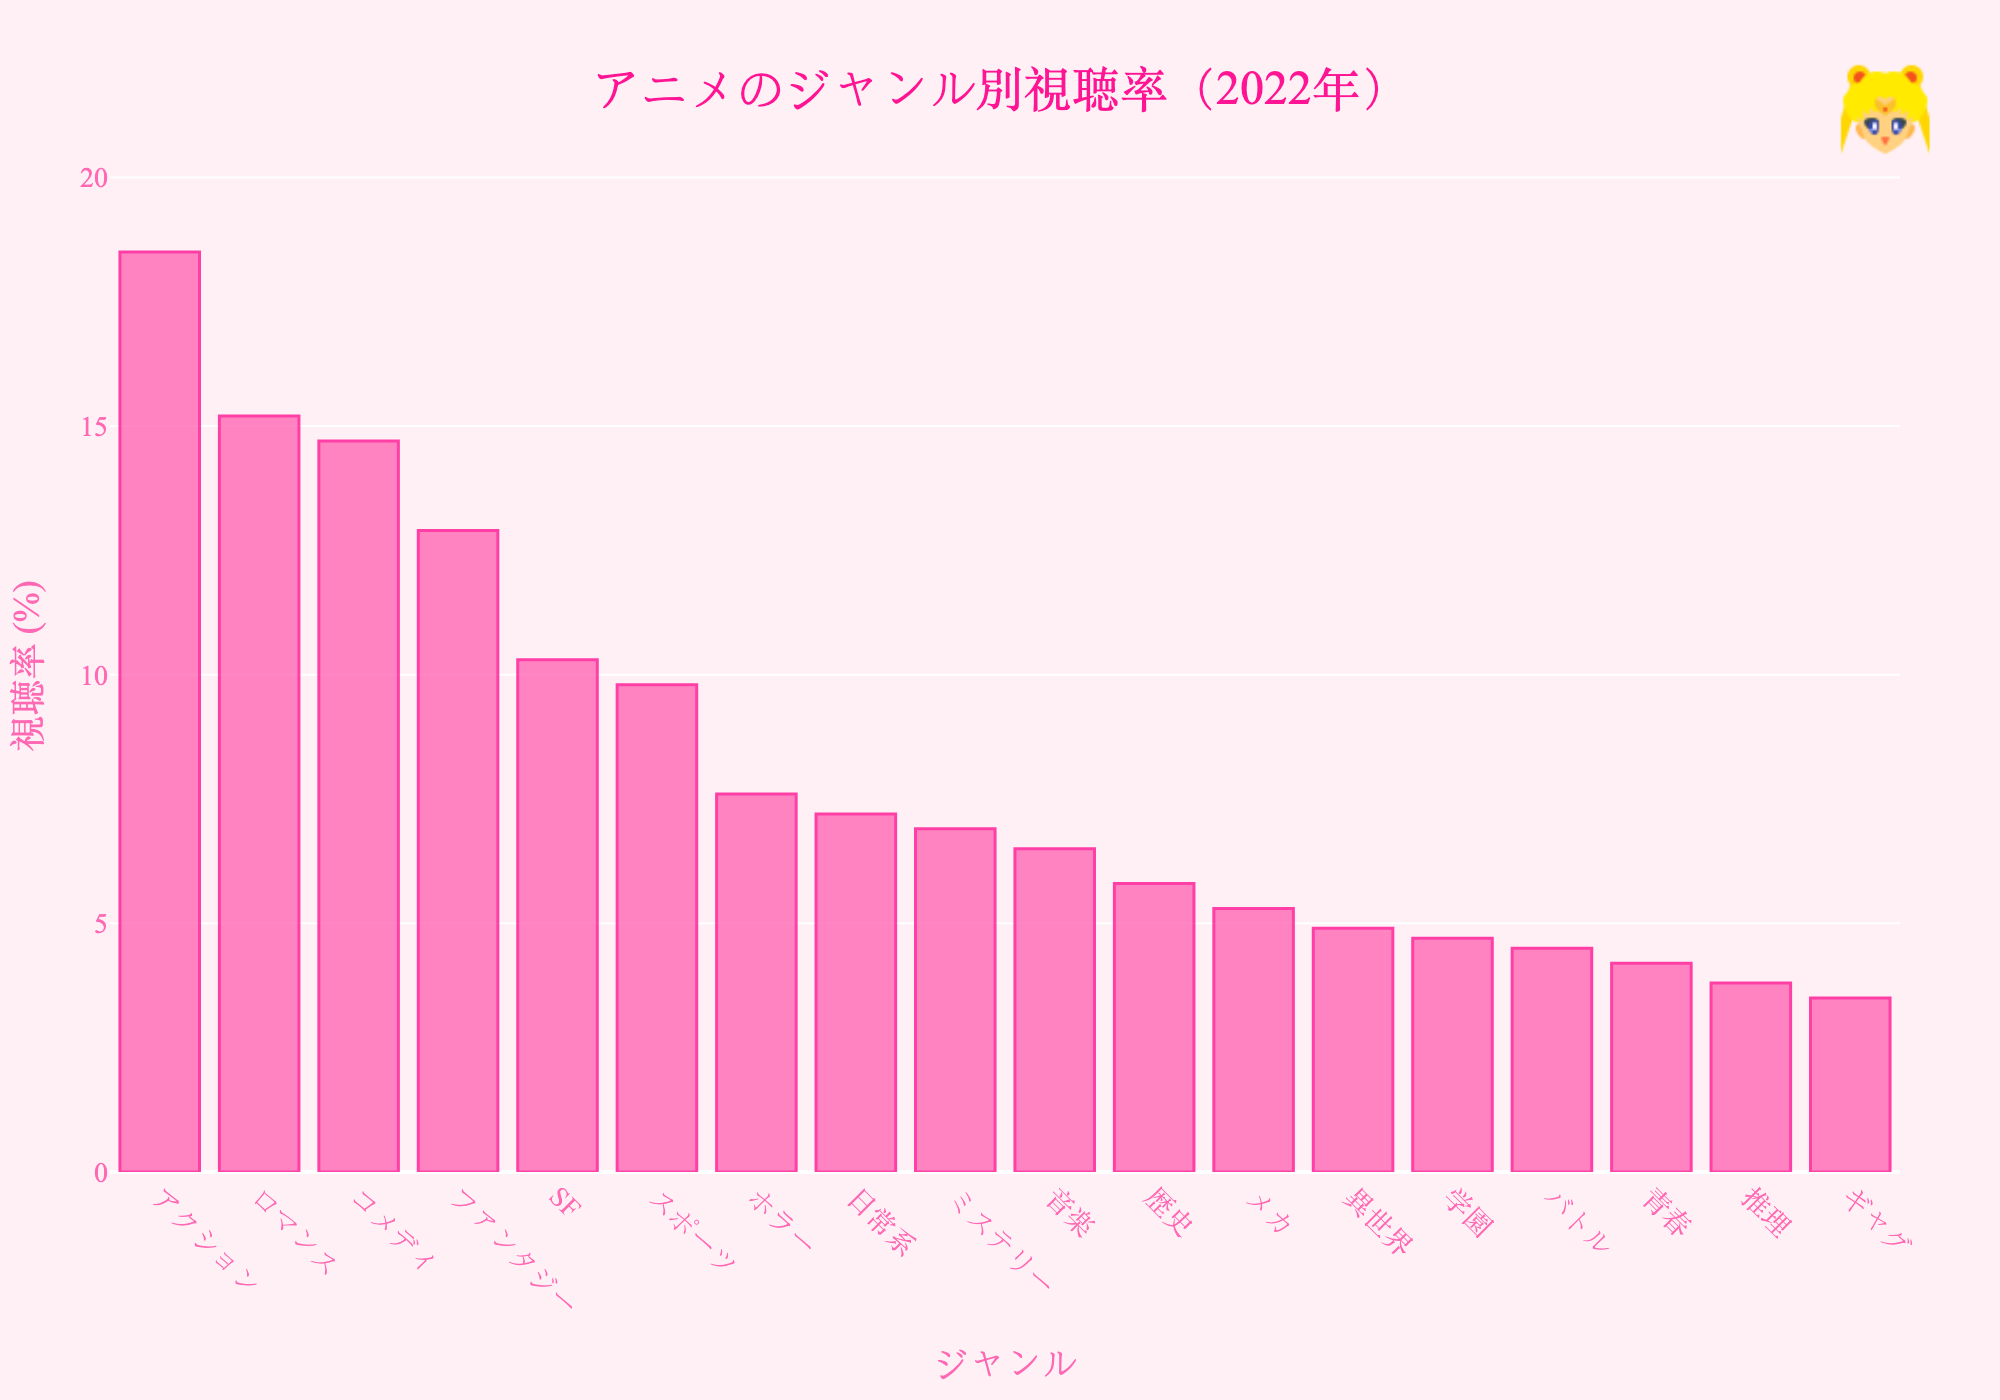アクションジャンルの視聴率は他のジャンルに比べて高いですか？ グラフを見て一目でわかるように、アクションジャンルのバーが最も高いです。つまり、視聴率が一番高いです。
Answer: はい、最も高いです。 低視聴率のジャンルはどれですか？ グラフの一番左端（または一番下）のバーが一番短いです。特に、ボス意:3.5%。
Answer: ギャグ アクションとロマンスの視聴率の差はいくらですか？ アクションの視聴率は18.5%、ロマンスは15.2%です。18.5% - 15.2% = 3.3% です。
Answer: 3.3% 視聴率が10%未満のジャンルはいくつありますか？ グラフのバーの長さを見て、それぞれのジャンルの視聴率が10%未満かを確認できます。該当するのはスポーツ、ホラー、日常系、ミステリー、音楽、歴史、メカ、異世界、学園、バトル、青春、推理、ギャグの13ジャンルです。
Answer: 13ジャンル ファンタジーとSFの視聴率を合わせるといくらですか？ ファンタジーの視聴率は12.9%、SFの視聴率は10.3%です。12.9% + 10.3% = 23.2% です。
Answer: 23.2% 一番多い視聴率と一番少ない視聴率のジャンルの視聴率の差はいくらですか？ アクションの視聴率は18.5%で最も高く、ギャグの視聴率は3.5%で最も低いです。18.5% - 3.5% = 15% です。
Answer: 15% アニメのジャンル別平均視聴率はどのくらいですか？ 全てのジャンルの視聴率を合計し、ジャンルの数で割ります。合計（18.5 + 15.2 + 14.7 + 12.9 + 10.3 + 9.8 + 7.6 + 7.2 + 6.9 + 6.5 + 5.8 + 5.3 + 4.9 + 4.7 + 4.5 + 4.2 + 3.8 + 3.5）= 146.4、ジャンルの数18で割ると、146.4 / 18 = 8.13% です。
Answer: 8.13% 視聴率が前から数えて5番目のジャンルは何ですか？ グラフのバーの順番を見て、視聴率が高い順に並んでいます。5番目のバーはSFです。
Answer: SF 